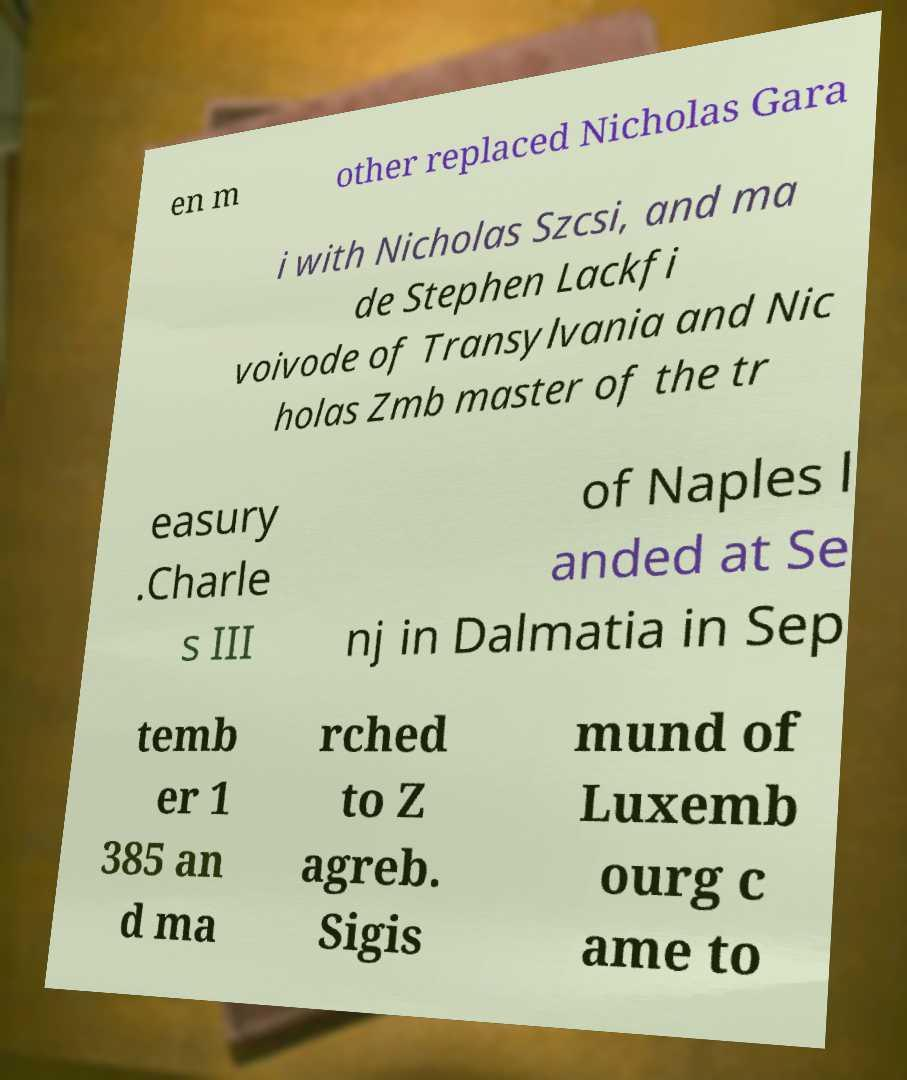I need the written content from this picture converted into text. Can you do that? en m other replaced Nicholas Gara i with Nicholas Szcsi, and ma de Stephen Lackfi voivode of Transylvania and Nic holas Zmb master of the tr easury .Charle s III of Naples l anded at Se nj in Dalmatia in Sep temb er 1 385 an d ma rched to Z agreb. Sigis mund of Luxemb ourg c ame to 